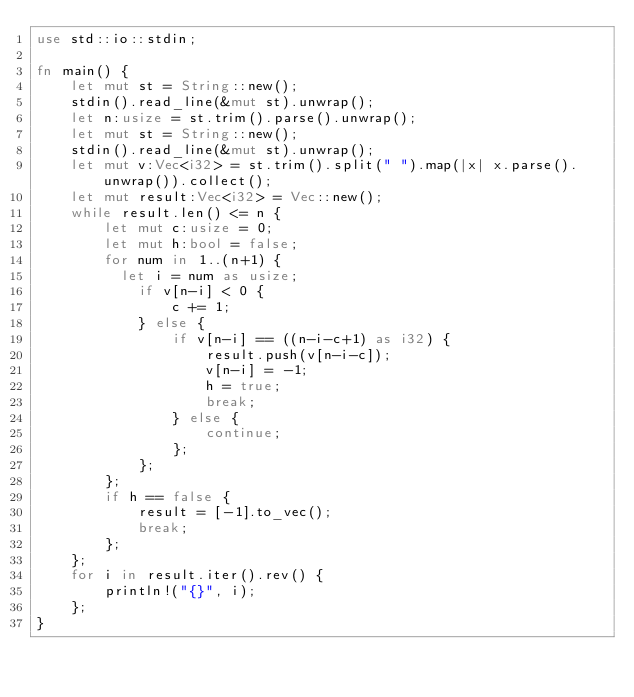<code> <loc_0><loc_0><loc_500><loc_500><_Rust_>use std::io::stdin;

fn main() {
    let mut st = String::new();
    stdin().read_line(&mut st).unwrap();
    let n:usize = st.trim().parse().unwrap();
    let mut st = String::new();
    stdin().read_line(&mut st).unwrap();
    let mut v:Vec<i32> = st.trim().split(" ").map(|x| x.parse().unwrap()).collect();
    let mut result:Vec<i32> = Vec::new();
    while result.len() <= n {
        let mut c:usize = 0;
        let mut h:bool = false;
        for num in 1..(n+1) {
        	let i = num as usize;
            if v[n-i] < 0 {
                c += 1;
            } else {
                if v[n-i] == ((n-i-c+1) as i32) {
                    result.push(v[n-i-c]);
                    v[n-i] = -1;
                    h = true;
                    break;
                } else {
                    continue;
                };
            };
        };
        if h == false {
            result = [-1].to_vec();
            break;
        };
    };
    for i in result.iter().rev() {
        println!("{}", i);
    };
}</code> 